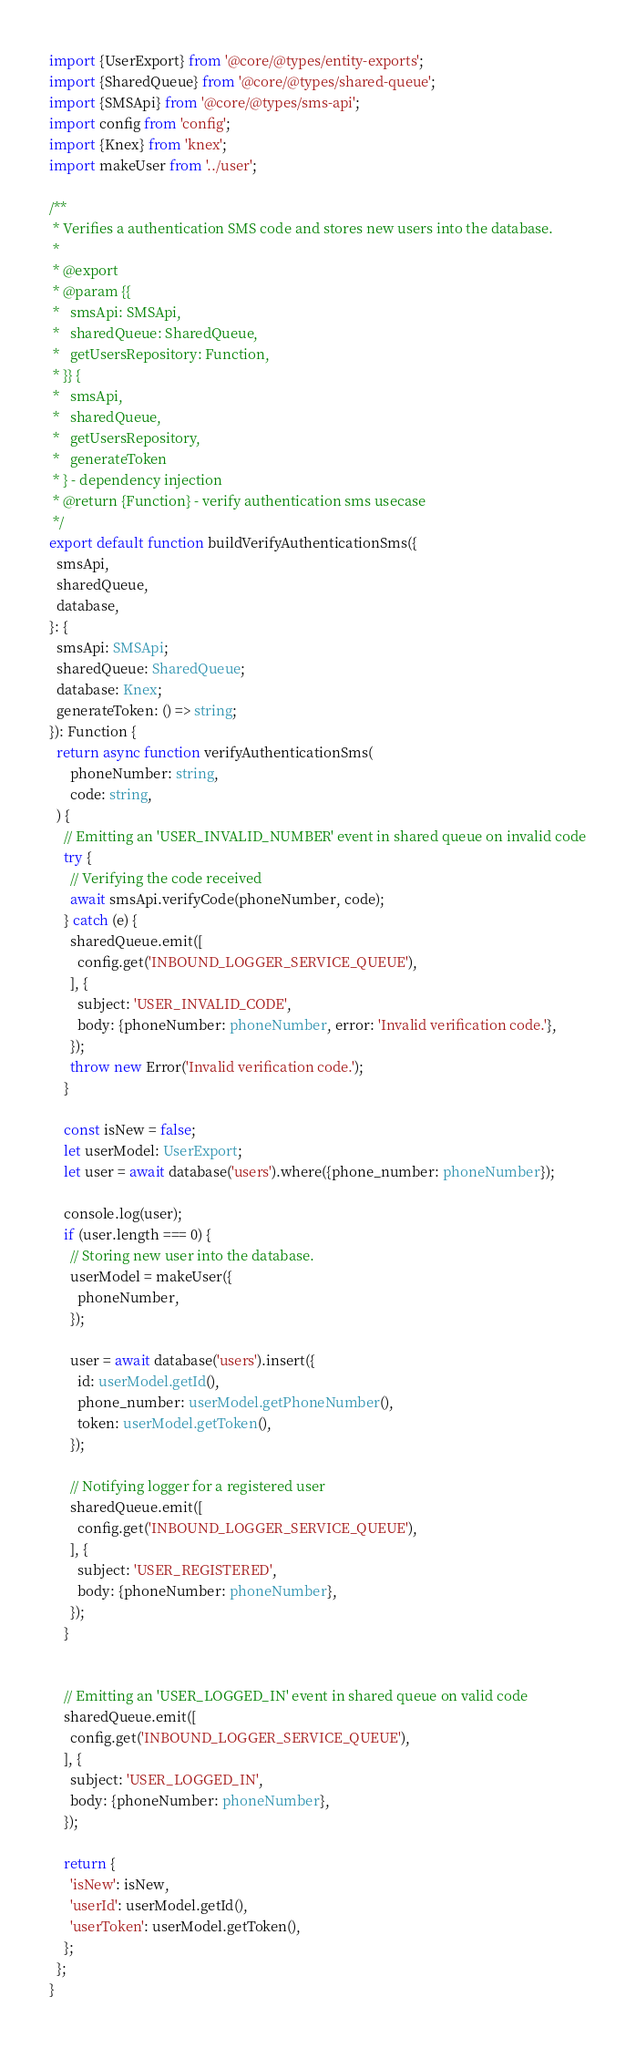Convert code to text. <code><loc_0><loc_0><loc_500><loc_500><_TypeScript_>import {UserExport} from '@core/@types/entity-exports';
import {SharedQueue} from '@core/@types/shared-queue';
import {SMSApi} from '@core/@types/sms-api';
import config from 'config';
import {Knex} from 'knex';
import makeUser from '../user';

/**
 * Verifies a authentication SMS code and stores new users into the database.
 *
 * @export
 * @param {{
 *   smsApi: SMSApi,
 *   sharedQueue: SharedQueue,
 *   getUsersRepository: Function,
 * }} {
 *   smsApi,
 *   sharedQueue,
 *   getUsersRepository,
 *   generateToken
 * } - dependency injection
 * @return {Function} - verify authentication sms usecase
 */
export default function buildVerifyAuthenticationSms({
  smsApi,
  sharedQueue,
  database,
}: {
  smsApi: SMSApi;
  sharedQueue: SharedQueue;
  database: Knex;
  generateToken: () => string;
}): Function {
  return async function verifyAuthenticationSms(
      phoneNumber: string,
      code: string,
  ) {
    // Emitting an 'USER_INVALID_NUMBER' event in shared queue on invalid code
    try {
      // Verifying the code received
      await smsApi.verifyCode(phoneNumber, code);
    } catch (e) {
      sharedQueue.emit([
        config.get('INBOUND_LOGGER_SERVICE_QUEUE'),
      ], {
        subject: 'USER_INVALID_CODE',
        body: {phoneNumber: phoneNumber, error: 'Invalid verification code.'},
      });
      throw new Error('Invalid verification code.');
    }

    const isNew = false;
    let userModel: UserExport;
    let user = await database('users').where({phone_number: phoneNumber});

    console.log(user);
    if (user.length === 0) {
      // Storing new user into the database.
      userModel = makeUser({
        phoneNumber,
      });

      user = await database('users').insert({
        id: userModel.getId(),
        phone_number: userModel.getPhoneNumber(),
        token: userModel.getToken(),
      });

      // Notifying logger for a registered user
      sharedQueue.emit([
        config.get('INBOUND_LOGGER_SERVICE_QUEUE'),
      ], {
        subject: 'USER_REGISTERED',
        body: {phoneNumber: phoneNumber},
      });
    }


    // Emitting an 'USER_LOGGED_IN' event in shared queue on valid code
    sharedQueue.emit([
      config.get('INBOUND_LOGGER_SERVICE_QUEUE'),
    ], {
      subject: 'USER_LOGGED_IN',
      body: {phoneNumber: phoneNumber},
    });

    return {
      'isNew': isNew,
      'userId': userModel.getId(),
      'userToken': userModel.getToken(),
    };
  };
}
</code> 